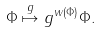<formula> <loc_0><loc_0><loc_500><loc_500>\Phi \stackrel { g } { \mapsto } g ^ { w ( \Phi ) } \Phi .</formula> 